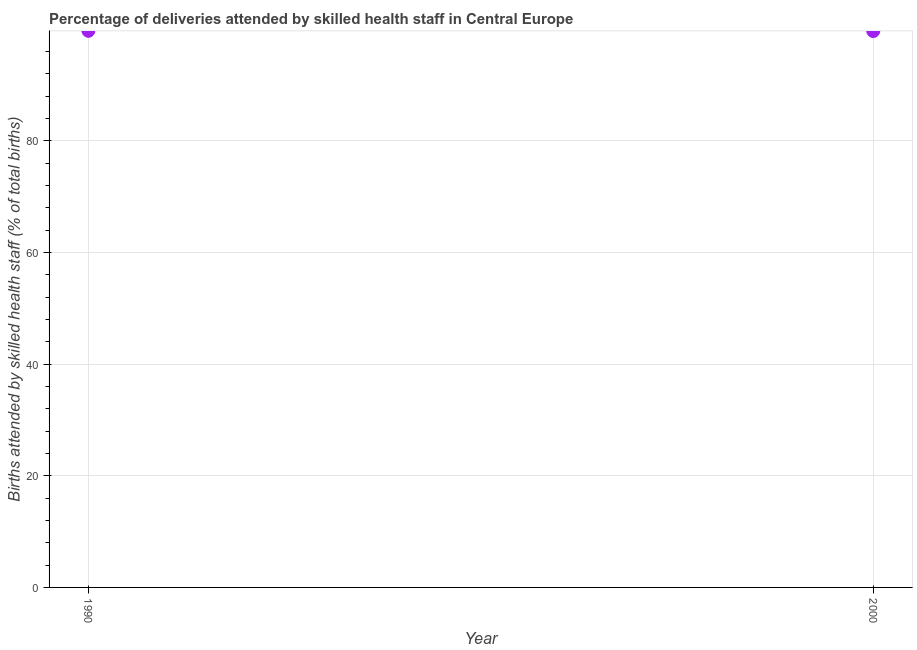What is the number of births attended by skilled health staff in 2000?
Provide a short and direct response. 99.63. Across all years, what is the maximum number of births attended by skilled health staff?
Give a very brief answer. 99.67. Across all years, what is the minimum number of births attended by skilled health staff?
Offer a very short reply. 99.63. What is the sum of the number of births attended by skilled health staff?
Give a very brief answer. 199.3. What is the difference between the number of births attended by skilled health staff in 1990 and 2000?
Give a very brief answer. 0.04. What is the average number of births attended by skilled health staff per year?
Provide a short and direct response. 99.65. What is the median number of births attended by skilled health staff?
Offer a very short reply. 99.65. In how many years, is the number of births attended by skilled health staff greater than 24 %?
Make the answer very short. 2. Do a majority of the years between 2000 and 1990 (inclusive) have number of births attended by skilled health staff greater than 20 %?
Keep it short and to the point. No. What is the ratio of the number of births attended by skilled health staff in 1990 to that in 2000?
Offer a terse response. 1. In how many years, is the number of births attended by skilled health staff greater than the average number of births attended by skilled health staff taken over all years?
Offer a very short reply. 1. Does the number of births attended by skilled health staff monotonically increase over the years?
Offer a very short reply. No. How many years are there in the graph?
Provide a short and direct response. 2. What is the difference between two consecutive major ticks on the Y-axis?
Offer a terse response. 20. Does the graph contain any zero values?
Make the answer very short. No. What is the title of the graph?
Your answer should be compact. Percentage of deliveries attended by skilled health staff in Central Europe. What is the label or title of the X-axis?
Offer a terse response. Year. What is the label or title of the Y-axis?
Your response must be concise. Births attended by skilled health staff (% of total births). What is the Births attended by skilled health staff (% of total births) in 1990?
Your answer should be compact. 99.67. What is the Births attended by skilled health staff (% of total births) in 2000?
Make the answer very short. 99.63. What is the difference between the Births attended by skilled health staff (% of total births) in 1990 and 2000?
Give a very brief answer. 0.04. What is the ratio of the Births attended by skilled health staff (% of total births) in 1990 to that in 2000?
Your answer should be compact. 1. 